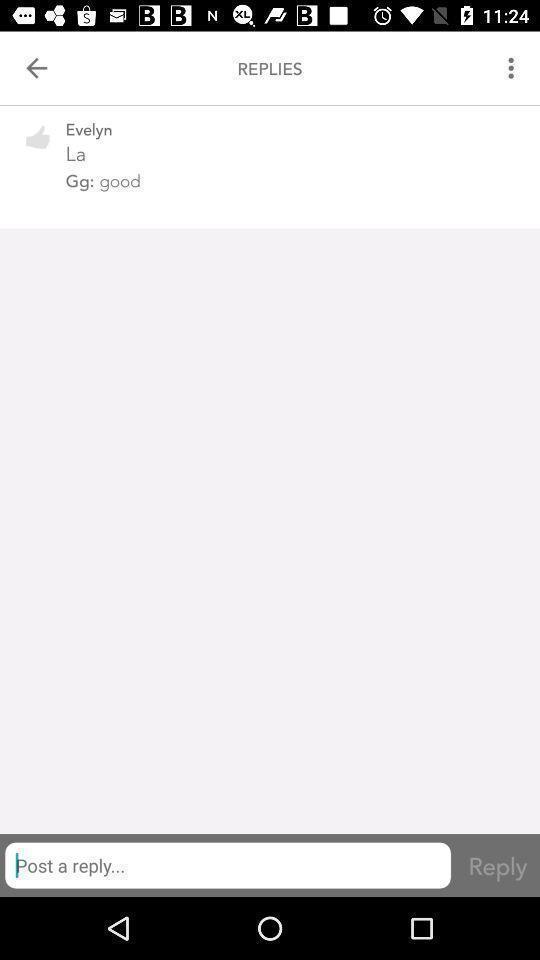Describe the key features of this screenshot. Shopping coupon app customer support chat interface. 